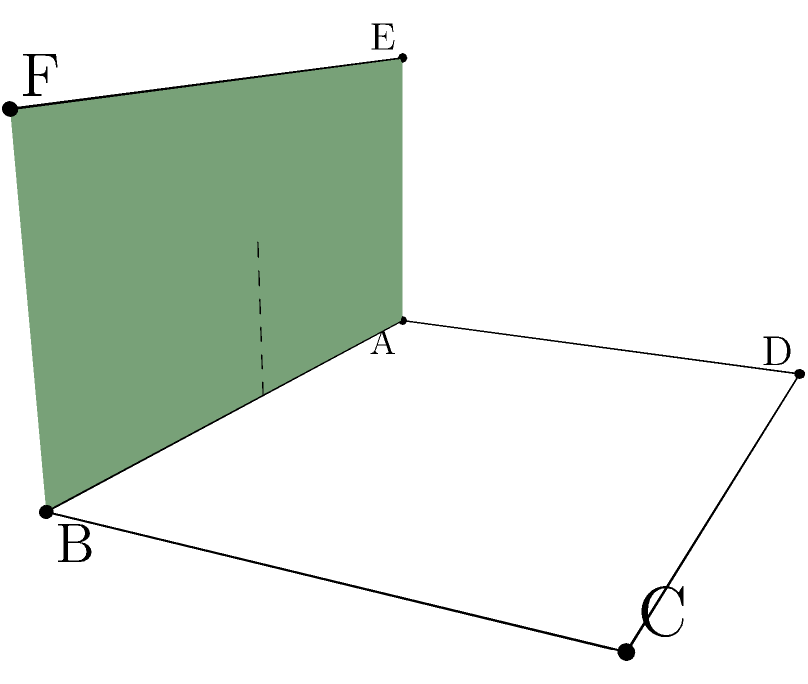A senior-friendly ramp is being designed for a community center in Boston. The ramp is 4 meters long and rises 2 meters in height. What is the angle $\theta$ (in degrees) between the ramp surface and the horizontal ground? To find the angle between the ramp surface and the horizontal ground, we can use trigonometry. Let's approach this step-by-step:

1) We have a right triangle formed by the ramp, where:
   - The base (adjacent side) is 4 meters long
   - The height (opposite side) is 2 meters

2) We need to find the angle $\theta$ between the hypotenuse (ramp surface) and the base (horizontal ground).

3) This can be done using the arctangent function:

   $\theta = \arctan(\frac{\text{opposite}}{\text{adjacent}})$

4) Plugging in our values:

   $\theta = \arctan(\frac{2}{4})$

5) Simplify:

   $\theta = \arctan(0.5)$

6) Calculate:

   $\theta \approx 26.57°$

7) Round to two decimal places:

   $\theta \approx 26.57°$

This angle ensures a gradual slope that is more manageable for seniors while still providing the necessary elevation.
Answer: $26.57°$ 